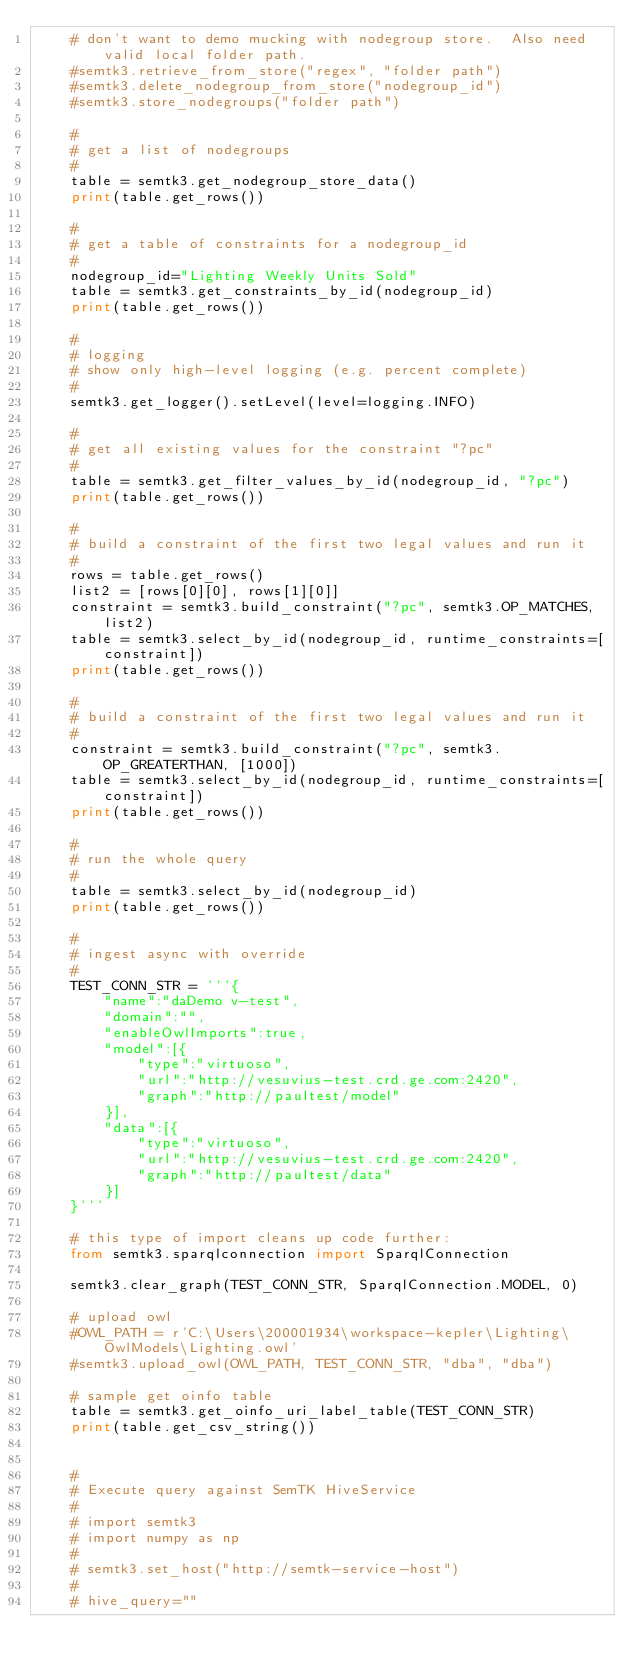Convert code to text. <code><loc_0><loc_0><loc_500><loc_500><_Python_>    # don't want to demo mucking with nodegroup store.  Also need valid local folder path.
    #semtk3.retrieve_from_store("regex", "folder path")
    #semtk3.delete_nodegroup_from_store("nodegroup_id")
    #semtk3.store_nodegroups("folder path")

    #
    # get a list of nodegroups
    #
    table = semtk3.get_nodegroup_store_data()
    print(table.get_rows())

    #
    # get a table of constraints for a nodegroup_id
    #
    nodegroup_id="Lighting Weekly Units Sold"
    table = semtk3.get_constraints_by_id(nodegroup_id)
    print(table.get_rows())

    #
    # logging
    # show only high-level logging (e.g. percent complete)
    #
    semtk3.get_logger().setLevel(level=logging.INFO)

    #
    # get all existing values for the constraint "?pc"
    #
    table = semtk3.get_filter_values_by_id(nodegroup_id, "?pc")
    print(table.get_rows())

    #
    # build a constraint of the first two legal values and run it
    #
    rows = table.get_rows()
    list2 = [rows[0][0], rows[1][0]]
    constraint = semtk3.build_constraint("?pc", semtk3.OP_MATCHES, list2)
    table = semtk3.select_by_id(nodegroup_id, runtime_constraints=[constraint])
    print(table.get_rows())
    
    #
    # build a constraint of the first two legal values and run it
    #
    constraint = semtk3.build_constraint("?pc", semtk3.OP_GREATERTHAN, [1000])
    table = semtk3.select_by_id(nodegroup_id, runtime_constraints=[constraint])
    print(table.get_rows())

    #
    # run the whole query
    #
    table = semtk3.select_by_id(nodegroup_id)
    print(table.get_rows())

    #
    # ingest async with override
    #
    TEST_CONN_STR = '''{
        "name":"daDemo v-test",
        "domain":"",
        "enableOwlImports":true,
        "model":[{
            "type":"virtuoso",
            "url":"http://vesuvius-test.crd.ge.com:2420",
            "graph":"http://paultest/model"
        }],
        "data":[{
            "type":"virtuoso",
            "url":"http://vesuvius-test.crd.ge.com:2420",
            "graph":"http://paultest/data"
        }]
    }'''

    # this type of import cleans up code further:
    from semtk3.sparqlconnection import SparqlConnection

    semtk3.clear_graph(TEST_CONN_STR, SparqlConnection.MODEL, 0)

    # upload owl
    #OWL_PATH = r'C:\Users\200001934\workspace-kepler\Lighting\OwlModels\Lighting.owl'
    #semtk3.upload_owl(OWL_PATH, TEST_CONN_STR, "dba", "dba")

    # sample get oinfo table
    table = semtk3.get_oinfo_uri_label_table(TEST_CONN_STR)
    print(table.get_csv_string())


    #
    # Execute query against SemTK HiveService
    #
    # import semtk3
    # import numpy as np
    #
    # semtk3.set_host("http://semtk-service-host")
    #
    # hive_query=""</code> 